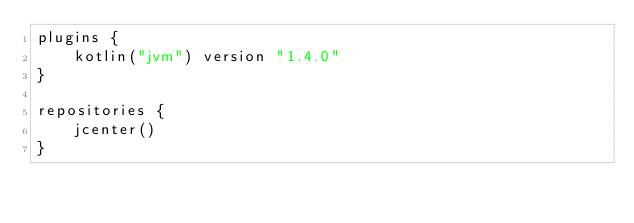Convert code to text. <code><loc_0><loc_0><loc_500><loc_500><_Kotlin_>plugins {
    kotlin("jvm") version "1.4.0"
}

repositories {
    jcenter()
}
</code> 